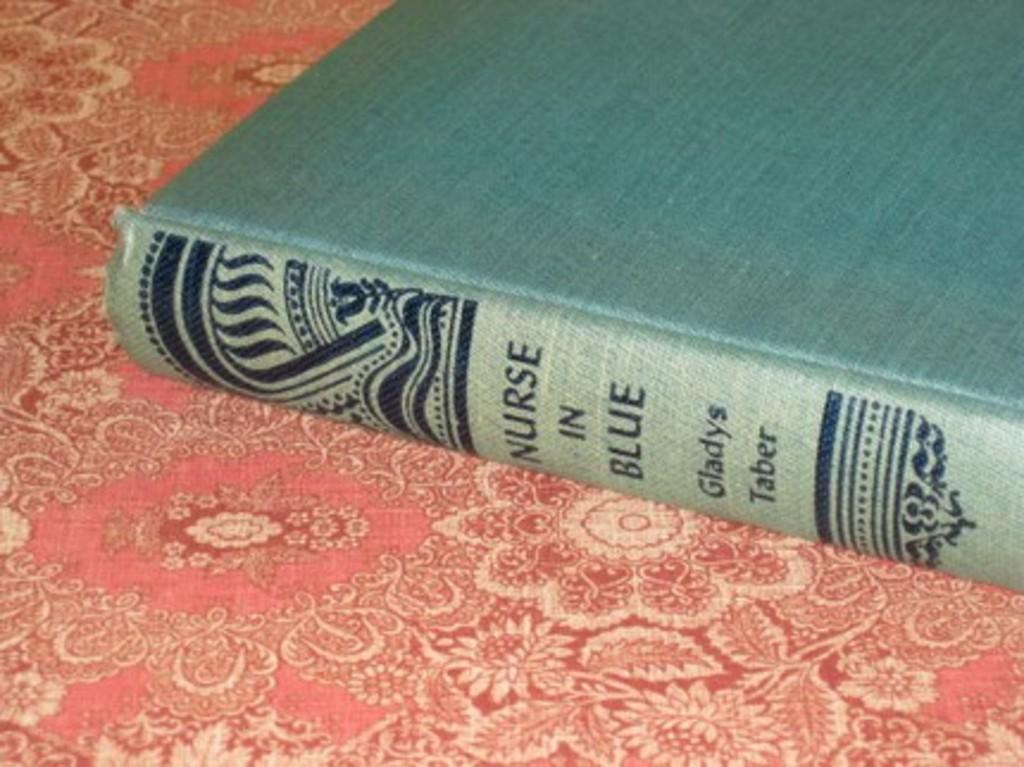What object is present in the image? There is a book in the image. What is the book placed on? The book is on a red color sheet. What is the color of the book? The book is green in color. What word is written on the book? The word "nurse" in blue color is written on the book. Can you see a nest in the image? There is no nest present in the image. What type of paint is used to write the word "nurse" on the book? The provided facts do not mention the type of paint used to write the word "nurse" on the book. --- Facts: 1. There is a person sitting on a chair in the image. 2. The person is holding a book. 3. The book is open. 4. The person is wearing glasses. 5. There is a table next to the chair. Absurd Topics: fish, dance, mountain Conversation: What is the person in the image doing? The person is sitting on a chair in the image. What object is the person holding? The person is holding a book. What is the state of the book? The book is open. What accessory is the person wearing? The person is wearing glasses. What is located next to the chair? There is a table next to the chair. Reasoning: Let's think step by step in order to produce the conversation. We start by identifying the main subject in the image, which is the person sitting on a chair. Then, we describe the person's actions and the objects they are holding or interacting with, such as the book and glasses. Finally, we mention the presence of a table next to the chair. Each question is designed to elicit a specific detail about the image that is known from the provided facts. Absurd Question/Answer: Can you see any fish swimming in the image? There is no fish present in the image. Is the person in the image dancing? The provided facts do not mention any dancing in the image. --- Facts: 1. There is a car in the image. 2. The car is red in color. 3. The car has four wheels. 4. There are people inside the car. 5. The car has a sunroof. Absurd Topics: bird, ocean, volcano Conversation: What vehicle is present in the image? There is a car in the image. What is the color of the car? The car is red in color. How many wheels does the car have? The car has four wheels. Who is inside the car? There are people inside the car. What feature does the car have on its roof? The car has a sunroof. Reasoning: Let' 